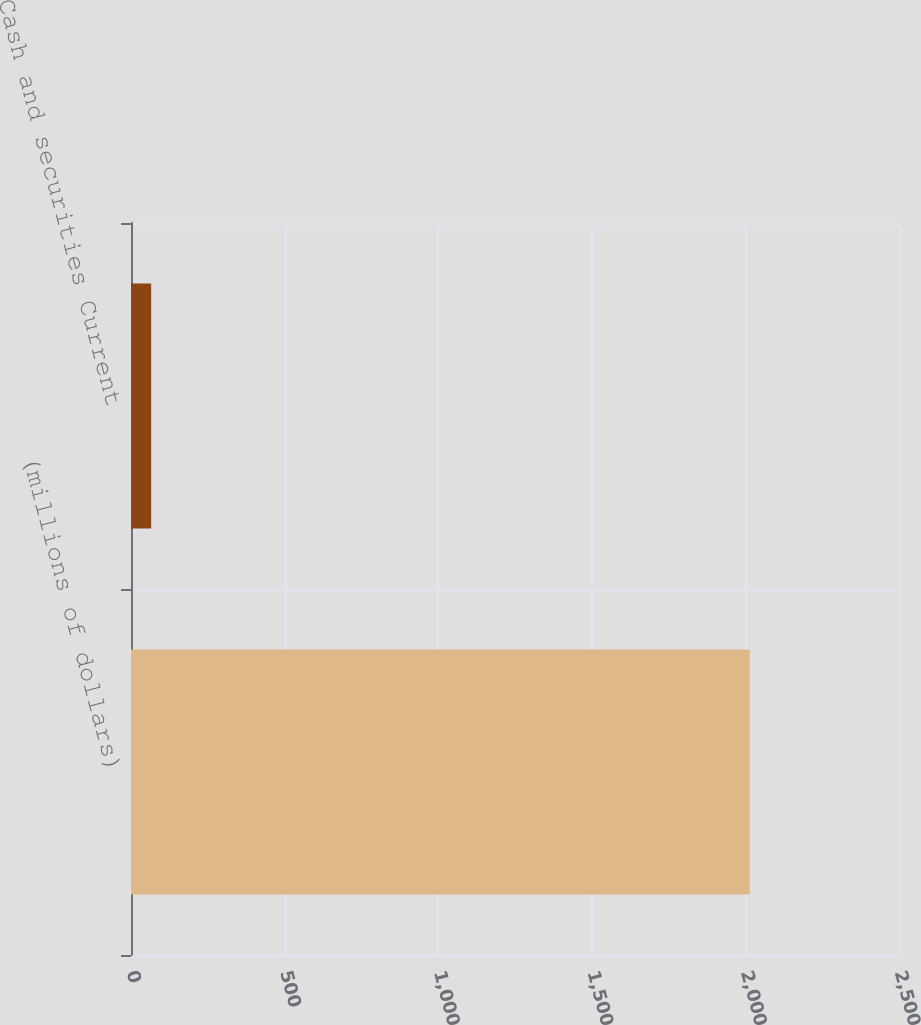Convert chart to OTSL. <chart><loc_0><loc_0><loc_500><loc_500><bar_chart><fcel>(millions of dollars)<fcel>Cash and securities Current<nl><fcel>2014<fcel>65.6<nl></chart> 